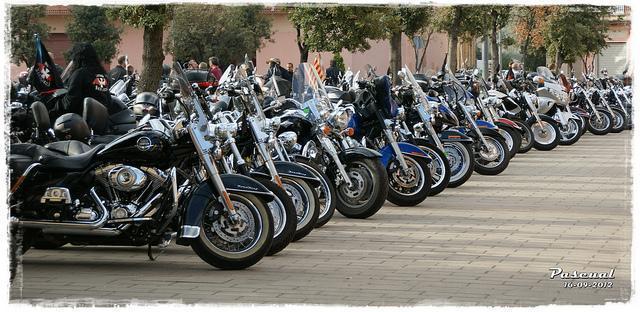How many motorcycles are visible?
Give a very brief answer. 8. 